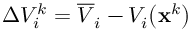<formula> <loc_0><loc_0><loc_500><loc_500>\Delta V _ { i } ^ { k } = \overline { V } _ { i } - V _ { i } \left ( x ^ { k } \right )</formula> 